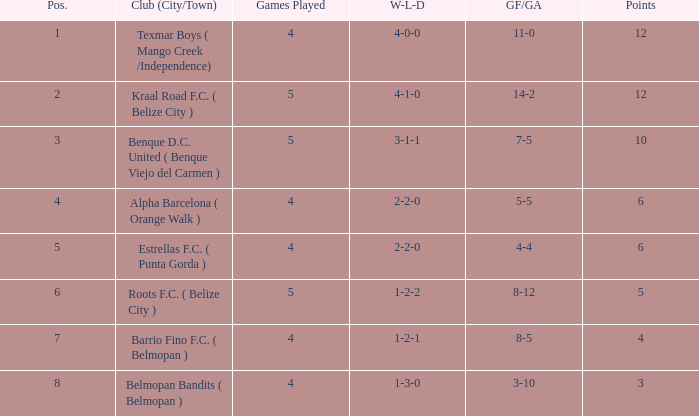What's the w-l-d with position being 1 4-0-0. 